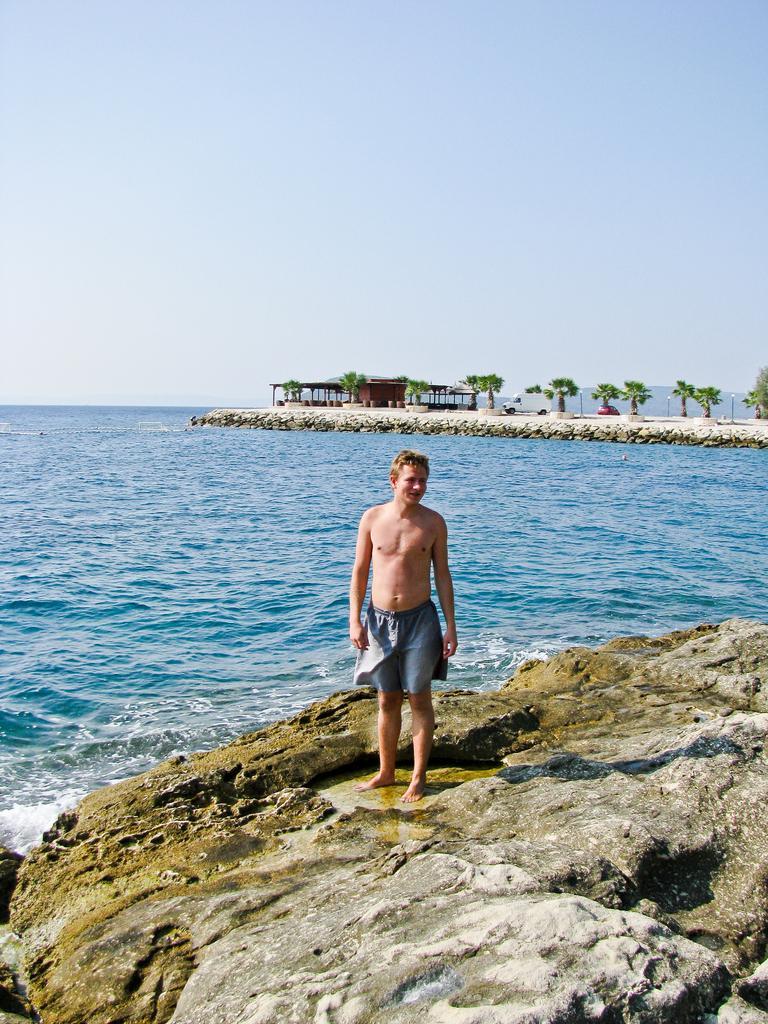In one or two sentences, can you explain what this image depicts? In this image I can see one person standing on the rock, near there is an ocean, beside I can see the trees and one shelter. 